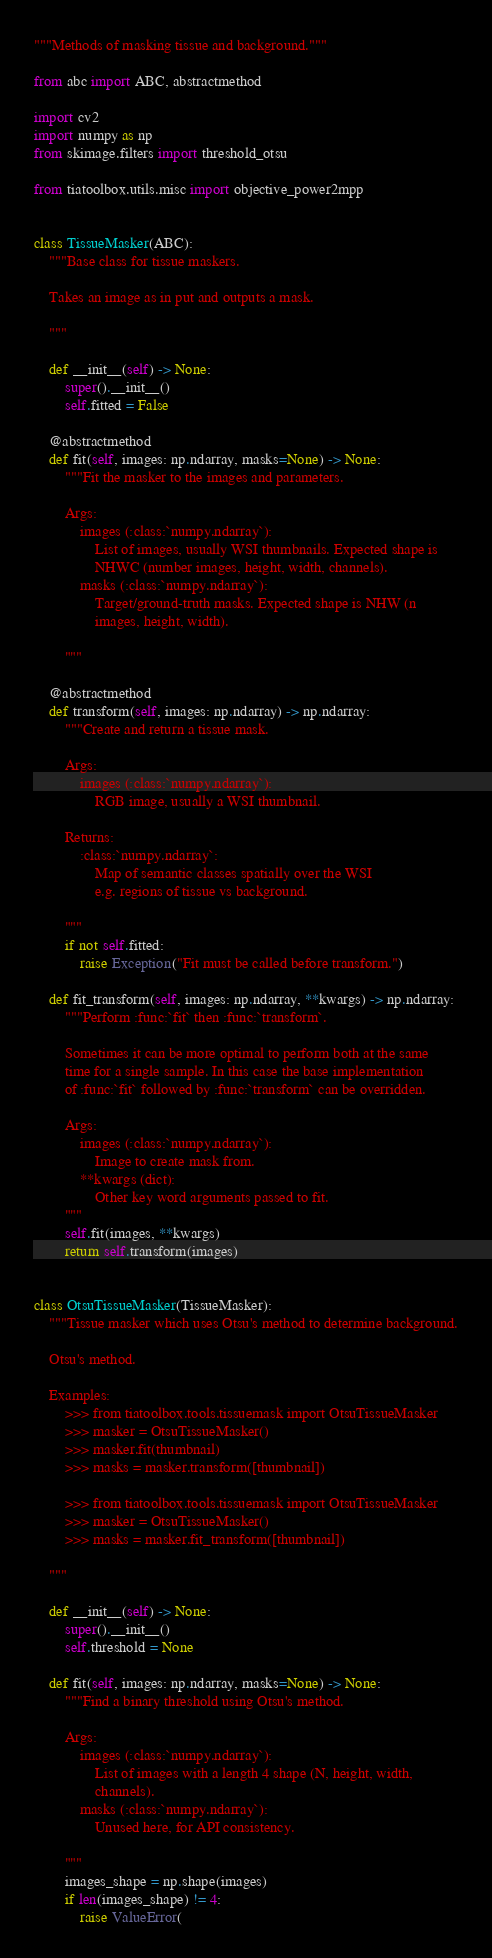Convert code to text. <code><loc_0><loc_0><loc_500><loc_500><_Python_>"""Methods of masking tissue and background."""

from abc import ABC, abstractmethod

import cv2
import numpy as np
from skimage.filters import threshold_otsu

from tiatoolbox.utils.misc import objective_power2mpp


class TissueMasker(ABC):
    """Base class for tissue maskers.

    Takes an image as in put and outputs a mask.

    """

    def __init__(self) -> None:
        super().__init__()
        self.fitted = False

    @abstractmethod
    def fit(self, images: np.ndarray, masks=None) -> None:
        """Fit the masker to the images and parameters.

        Args:
            images (:class:`numpy.ndarray`):
                List of images, usually WSI thumbnails. Expected shape is
                NHWC (number images, height, width, channels).
            masks (:class:`numpy.ndarray`):
                Target/ground-truth masks. Expected shape is NHW (n
                images, height, width).

        """

    @abstractmethod
    def transform(self, images: np.ndarray) -> np.ndarray:
        """Create and return a tissue mask.

        Args:
            images (:class:`numpy.ndarray`):
                RGB image, usually a WSI thumbnail.

        Returns:
            :class:`numpy.ndarray`:
                Map of semantic classes spatially over the WSI
                e.g. regions of tissue vs background.

        """
        if not self.fitted:
            raise Exception("Fit must be called before transform.")

    def fit_transform(self, images: np.ndarray, **kwargs) -> np.ndarray:
        """Perform :func:`fit` then :func:`transform`.

        Sometimes it can be more optimal to perform both at the same
        time for a single sample. In this case the base implementation
        of :func:`fit` followed by :func:`transform` can be overridden.

        Args:
            images (:class:`numpy.ndarray`):
                Image to create mask from.
            **kwargs (dict):
                Other key word arguments passed to fit.
        """
        self.fit(images, **kwargs)
        return self.transform(images)


class OtsuTissueMasker(TissueMasker):
    """Tissue masker which uses Otsu's method to determine background.

    Otsu's method.

    Examples:
        >>> from tiatoolbox.tools.tissuemask import OtsuTissueMasker
        >>> masker = OtsuTissueMasker()
        >>> masker.fit(thumbnail)
        >>> masks = masker.transform([thumbnail])

        >>> from tiatoolbox.tools.tissuemask import OtsuTissueMasker
        >>> masker = OtsuTissueMasker()
        >>> masks = masker.fit_transform([thumbnail])

    """

    def __init__(self) -> None:
        super().__init__()
        self.threshold = None

    def fit(self, images: np.ndarray, masks=None) -> None:
        """Find a binary threshold using Otsu's method.

        Args:
            images (:class:`numpy.ndarray`):
                List of images with a length 4 shape (N, height, width,
                channels).
            masks (:class:`numpy.ndarray`):
                Unused here, for API consistency.

        """
        images_shape = np.shape(images)
        if len(images_shape) != 4:
            raise ValueError(</code> 